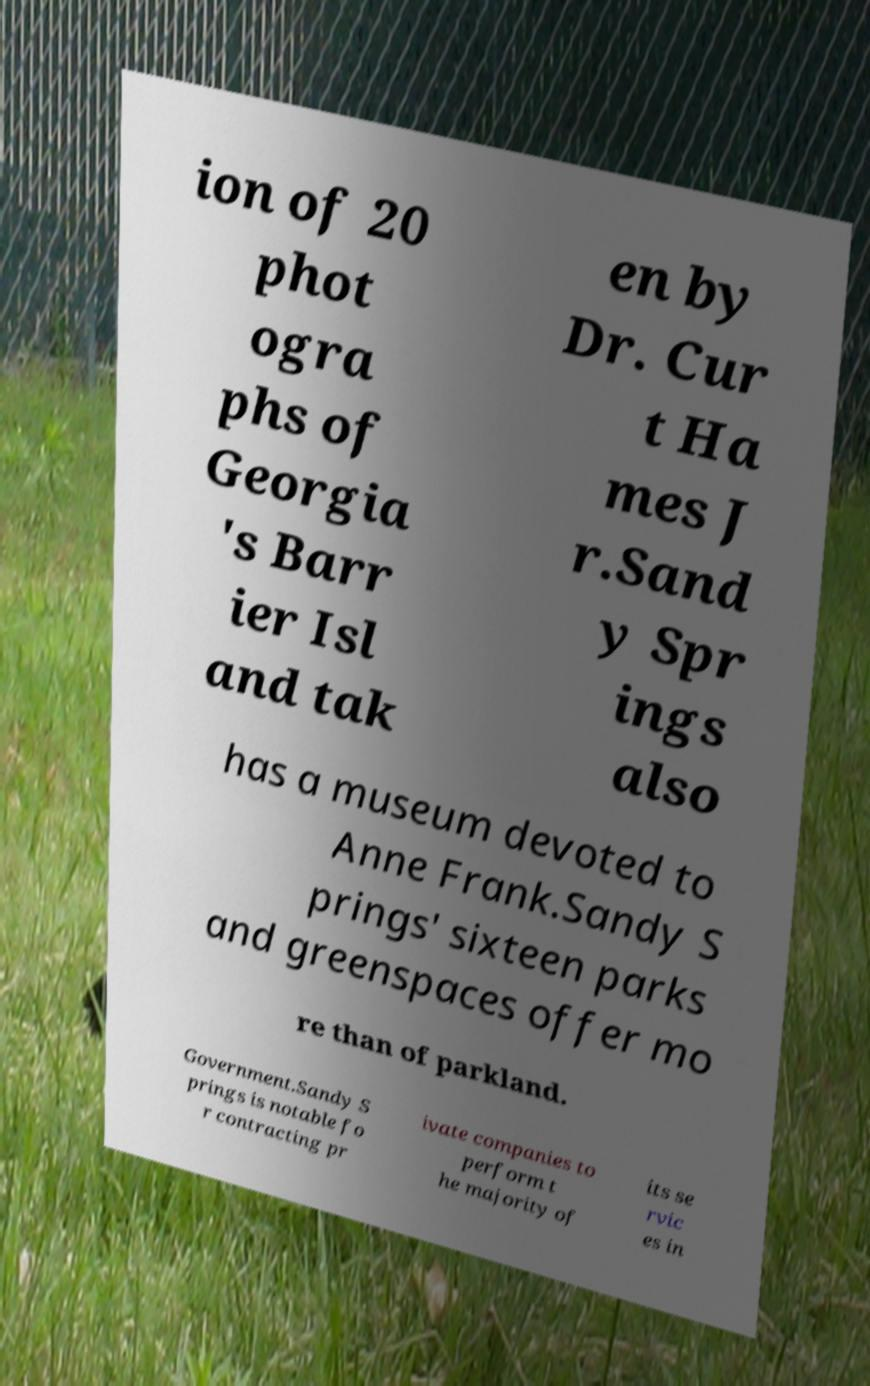Can you accurately transcribe the text from the provided image for me? ion of 20 phot ogra phs of Georgia 's Barr ier Isl and tak en by Dr. Cur t Ha mes J r.Sand y Spr ings also has a museum devoted to Anne Frank.Sandy S prings' sixteen parks and greenspaces offer mo re than of parkland. Government.Sandy S prings is notable fo r contracting pr ivate companies to perform t he majority of its se rvic es in 